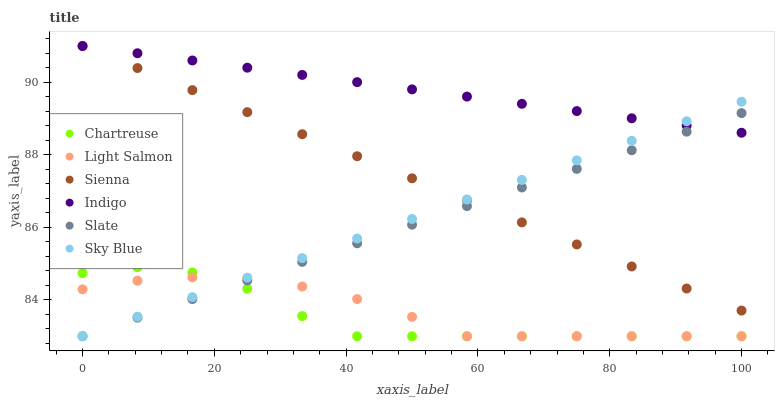Does Chartreuse have the minimum area under the curve?
Answer yes or no. Yes. Does Indigo have the maximum area under the curve?
Answer yes or no. Yes. Does Slate have the minimum area under the curve?
Answer yes or no. No. Does Slate have the maximum area under the curve?
Answer yes or no. No. Is Slate the smoothest?
Answer yes or no. Yes. Is Chartreuse the roughest?
Answer yes or no. Yes. Is Indigo the smoothest?
Answer yes or no. No. Is Indigo the roughest?
Answer yes or no. No. Does Light Salmon have the lowest value?
Answer yes or no. Yes. Does Indigo have the lowest value?
Answer yes or no. No. Does Sienna have the highest value?
Answer yes or no. Yes. Does Slate have the highest value?
Answer yes or no. No. Is Chartreuse less than Indigo?
Answer yes or no. Yes. Is Indigo greater than Light Salmon?
Answer yes or no. Yes. Does Slate intersect Chartreuse?
Answer yes or no. Yes. Is Slate less than Chartreuse?
Answer yes or no. No. Is Slate greater than Chartreuse?
Answer yes or no. No. Does Chartreuse intersect Indigo?
Answer yes or no. No. 